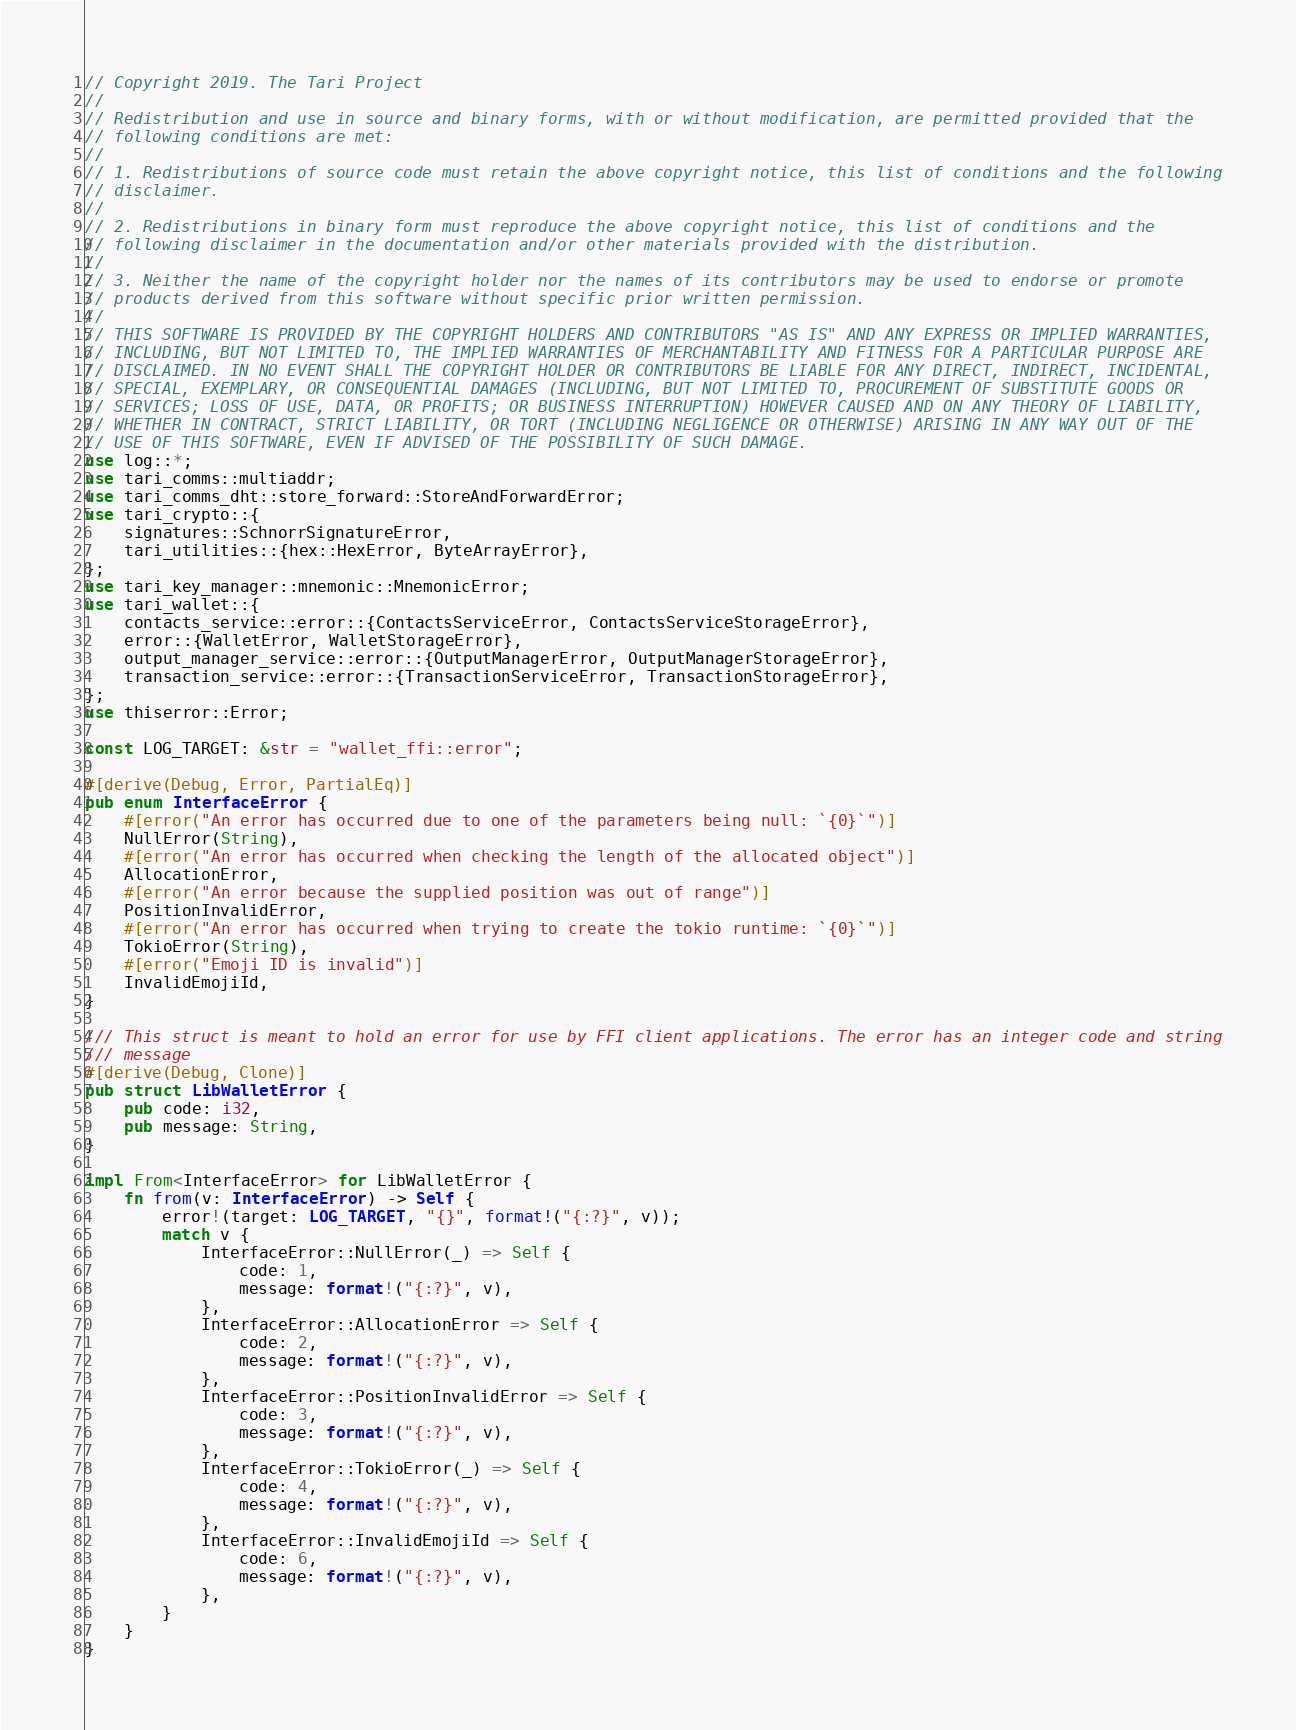<code> <loc_0><loc_0><loc_500><loc_500><_Rust_>// Copyright 2019. The Tari Project
//
// Redistribution and use in source and binary forms, with or without modification, are permitted provided that the
// following conditions are met:
//
// 1. Redistributions of source code must retain the above copyright notice, this list of conditions and the following
// disclaimer.
//
// 2. Redistributions in binary form must reproduce the above copyright notice, this list of conditions and the
// following disclaimer in the documentation and/or other materials provided with the distribution.
//
// 3. Neither the name of the copyright holder nor the names of its contributors may be used to endorse or promote
// products derived from this software without specific prior written permission.
//
// THIS SOFTWARE IS PROVIDED BY THE COPYRIGHT HOLDERS AND CONTRIBUTORS "AS IS" AND ANY EXPRESS OR IMPLIED WARRANTIES,
// INCLUDING, BUT NOT LIMITED TO, THE IMPLIED WARRANTIES OF MERCHANTABILITY AND FITNESS FOR A PARTICULAR PURPOSE ARE
// DISCLAIMED. IN NO EVENT SHALL THE COPYRIGHT HOLDER OR CONTRIBUTORS BE LIABLE FOR ANY DIRECT, INDIRECT, INCIDENTAL,
// SPECIAL, EXEMPLARY, OR CONSEQUENTIAL DAMAGES (INCLUDING, BUT NOT LIMITED TO, PROCUREMENT OF SUBSTITUTE GOODS OR
// SERVICES; LOSS OF USE, DATA, OR PROFITS; OR BUSINESS INTERRUPTION) HOWEVER CAUSED AND ON ANY THEORY OF LIABILITY,
// WHETHER IN CONTRACT, STRICT LIABILITY, OR TORT (INCLUDING NEGLIGENCE OR OTHERWISE) ARISING IN ANY WAY OUT OF THE
// USE OF THIS SOFTWARE, EVEN IF ADVISED OF THE POSSIBILITY OF SUCH DAMAGE.
use log::*;
use tari_comms::multiaddr;
use tari_comms_dht::store_forward::StoreAndForwardError;
use tari_crypto::{
    signatures::SchnorrSignatureError,
    tari_utilities::{hex::HexError, ByteArrayError},
};
use tari_key_manager::mnemonic::MnemonicError;
use tari_wallet::{
    contacts_service::error::{ContactsServiceError, ContactsServiceStorageError},
    error::{WalletError, WalletStorageError},
    output_manager_service::error::{OutputManagerError, OutputManagerStorageError},
    transaction_service::error::{TransactionServiceError, TransactionStorageError},
};
use thiserror::Error;

const LOG_TARGET: &str = "wallet_ffi::error";

#[derive(Debug, Error, PartialEq)]
pub enum InterfaceError {
    #[error("An error has occurred due to one of the parameters being null: `{0}`")]
    NullError(String),
    #[error("An error has occurred when checking the length of the allocated object")]
    AllocationError,
    #[error("An error because the supplied position was out of range")]
    PositionInvalidError,
    #[error("An error has occurred when trying to create the tokio runtime: `{0}`")]
    TokioError(String),
    #[error("Emoji ID is invalid")]
    InvalidEmojiId,
}

/// This struct is meant to hold an error for use by FFI client applications. The error has an integer code and string
/// message
#[derive(Debug, Clone)]
pub struct LibWalletError {
    pub code: i32,
    pub message: String,
}

impl From<InterfaceError> for LibWalletError {
    fn from(v: InterfaceError) -> Self {
        error!(target: LOG_TARGET, "{}", format!("{:?}", v));
        match v {
            InterfaceError::NullError(_) => Self {
                code: 1,
                message: format!("{:?}", v),
            },
            InterfaceError::AllocationError => Self {
                code: 2,
                message: format!("{:?}", v),
            },
            InterfaceError::PositionInvalidError => Self {
                code: 3,
                message: format!("{:?}", v),
            },
            InterfaceError::TokioError(_) => Self {
                code: 4,
                message: format!("{:?}", v),
            },
            InterfaceError::InvalidEmojiId => Self {
                code: 6,
                message: format!("{:?}", v),
            },
        }
    }
}
</code> 